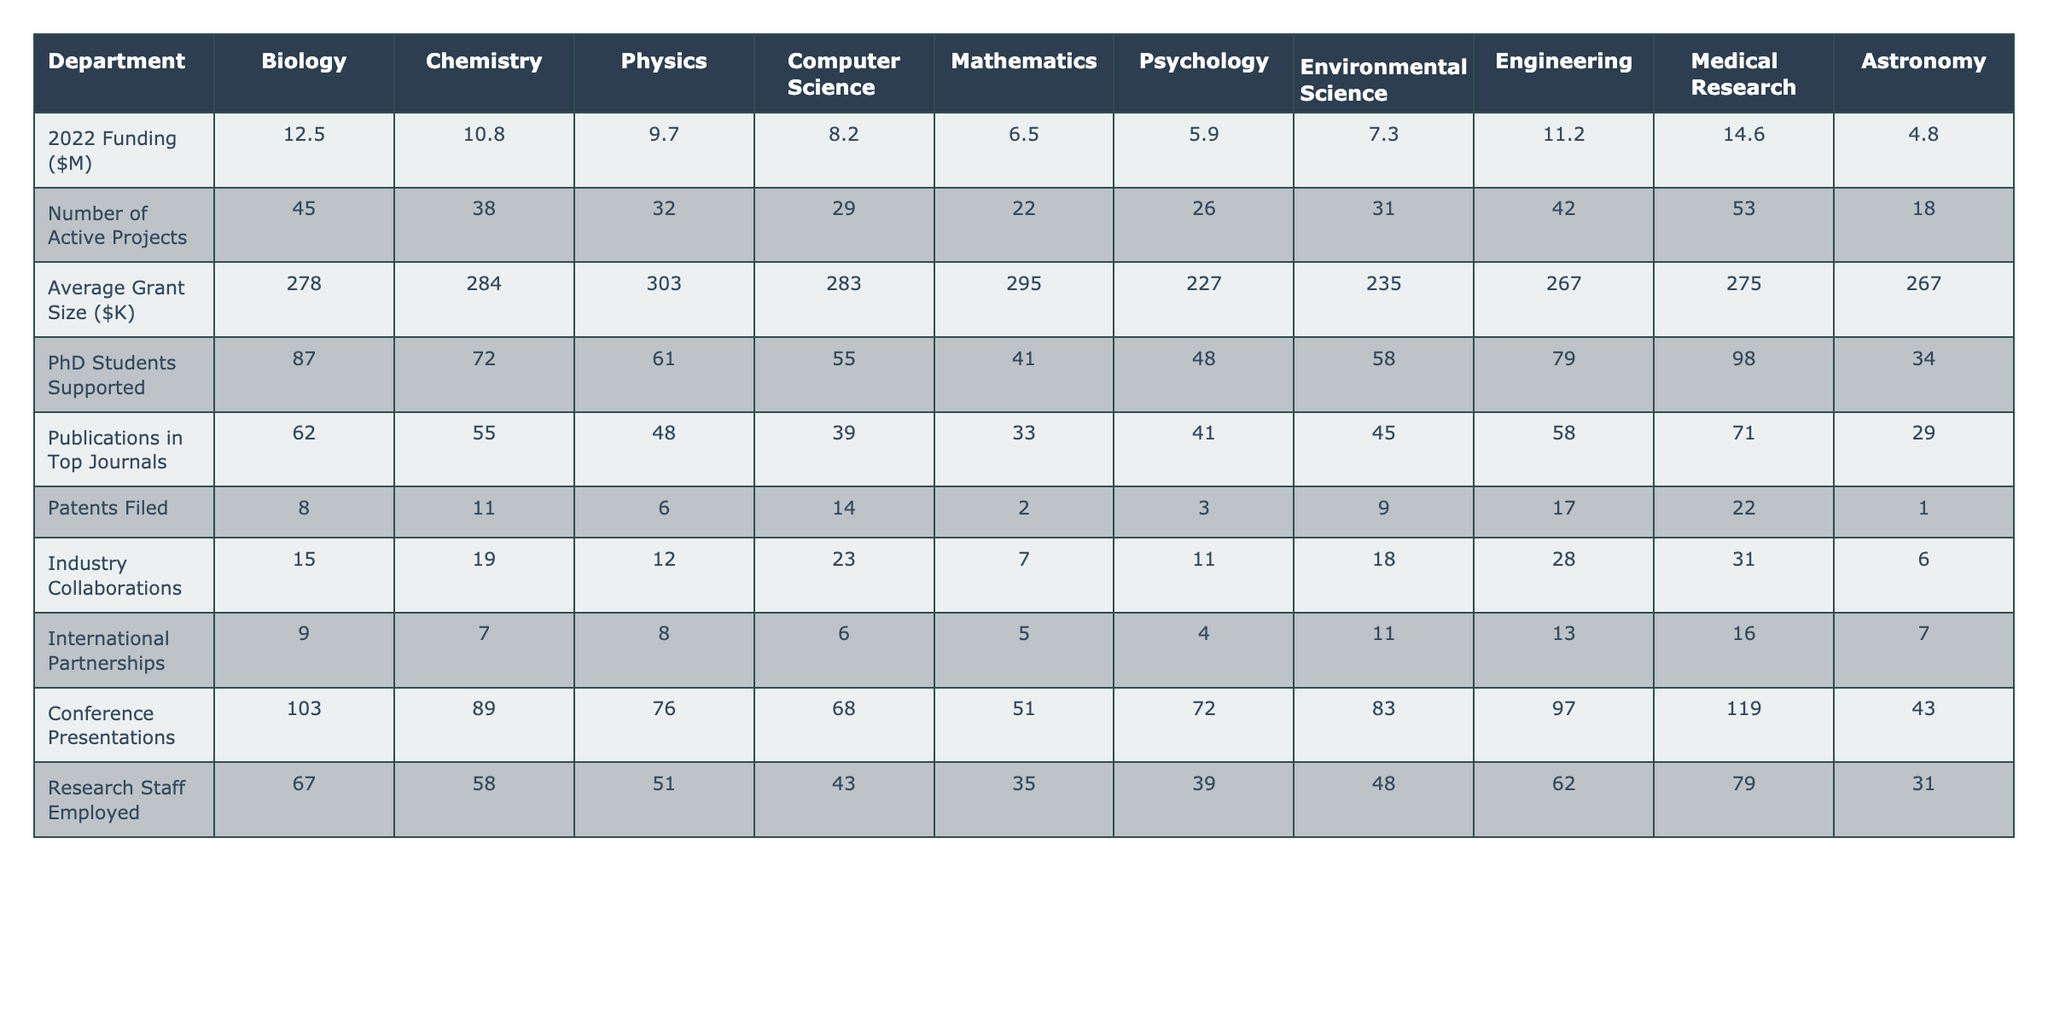What's the funding allocated to the Medical Research department? The funding amount for Medical Research is explicitly listed in the table as 14.6 million dollars.
Answer: 14.6 million dollars Which department has the highest number of active projects? The table shows the number of active projects for each department. Medical Research has the highest number at 53 active projects.
Answer: Medical Research What is the average grant size for the Physics department? The average grant size for Physics is found in the corresponding cell in the table, which is 303 thousand dollars.
Answer: 303 thousand dollars How many PhD students are supported in the Computer Science department? The number of PhD students supported in Computer Science is directly listed in the table as 55.
Answer: 55 Which scientific field has the lowest number of patents filed? By examining the patents filed column, we see that Mathematics has the lowest number filed at 2.
Answer: Mathematics What is the total funding allocation for the Biology and Chemistry departments? To find the total, we sum the funding amounts: 12.5 (Biology) + 10.8 (Chemistry) = 23.3 million dollars.
Answer: 23.3 million dollars Is the average grant size higher in Engineering than in Psychology? The average grant size for Engineering is 267 thousand dollars, while for Psychology, it is 227 thousand dollars, indicating that Engineering has a higher grant size.
Answer: Yes Which department has the least amount of funding, and what is that amount? The least funding can be determined from the funding column; Astronomy has the lowest at 4.8 million dollars.
Answer: Astronomy, 4.8 million dollars What is the difference in the number of conference presentations between Biology and Physics? The number of conference presentations is 103 for Biology and 76 for Physics. The difference is 103 - 76 = 27.
Answer: 27 Are there more industry collaborations in the Engineering department compared to the Chemistry department? The data shows Engineering has 28 collaborations while Chemistry has 19. Therefore, Engineering has more collaborations.
Answer: Yes Which department supported the most PhD students, and how many were supported? By examining the PhD students supported column, Medical Research has the highest number with 98.
Answer: Medical Research, 98 What is the ratio of patents filed in Computer Science to those filed in Biology? The table states 14 patents filed in Computer Science and 8 in Biology, giving a ratio of 14:8, which simplifies to 7:4.
Answer: 7:4 How many departments have more than 70 publications in top journals? By reviewing the publications data, the departments with more than 70 publications are Biology (62), Chemistry (55), Medical Research (71), which makes a total of 3 departments.
Answer: 3 departments What’s the average funding across all departments? We sum the funding amounts: 12.5 + 10.8 + 9.7 + 8.2 + 6.5 + 5.9 + 7.3 + 11.2 + 14.6 + 4.8 = 75.5 million dollars, then divide by the total number of departments (10): 75.5 / 10 = 7.55 million dollars.
Answer: 7.55 million dollars Which department has a higher average grant size, Biology or Engineering? The average grant size for Biology is 278 thousand dollars, while for Engineering it is 267 thousand dollars. Since 278 is greater than 267, Biology has a higher average grant size.
Answer: Biology 